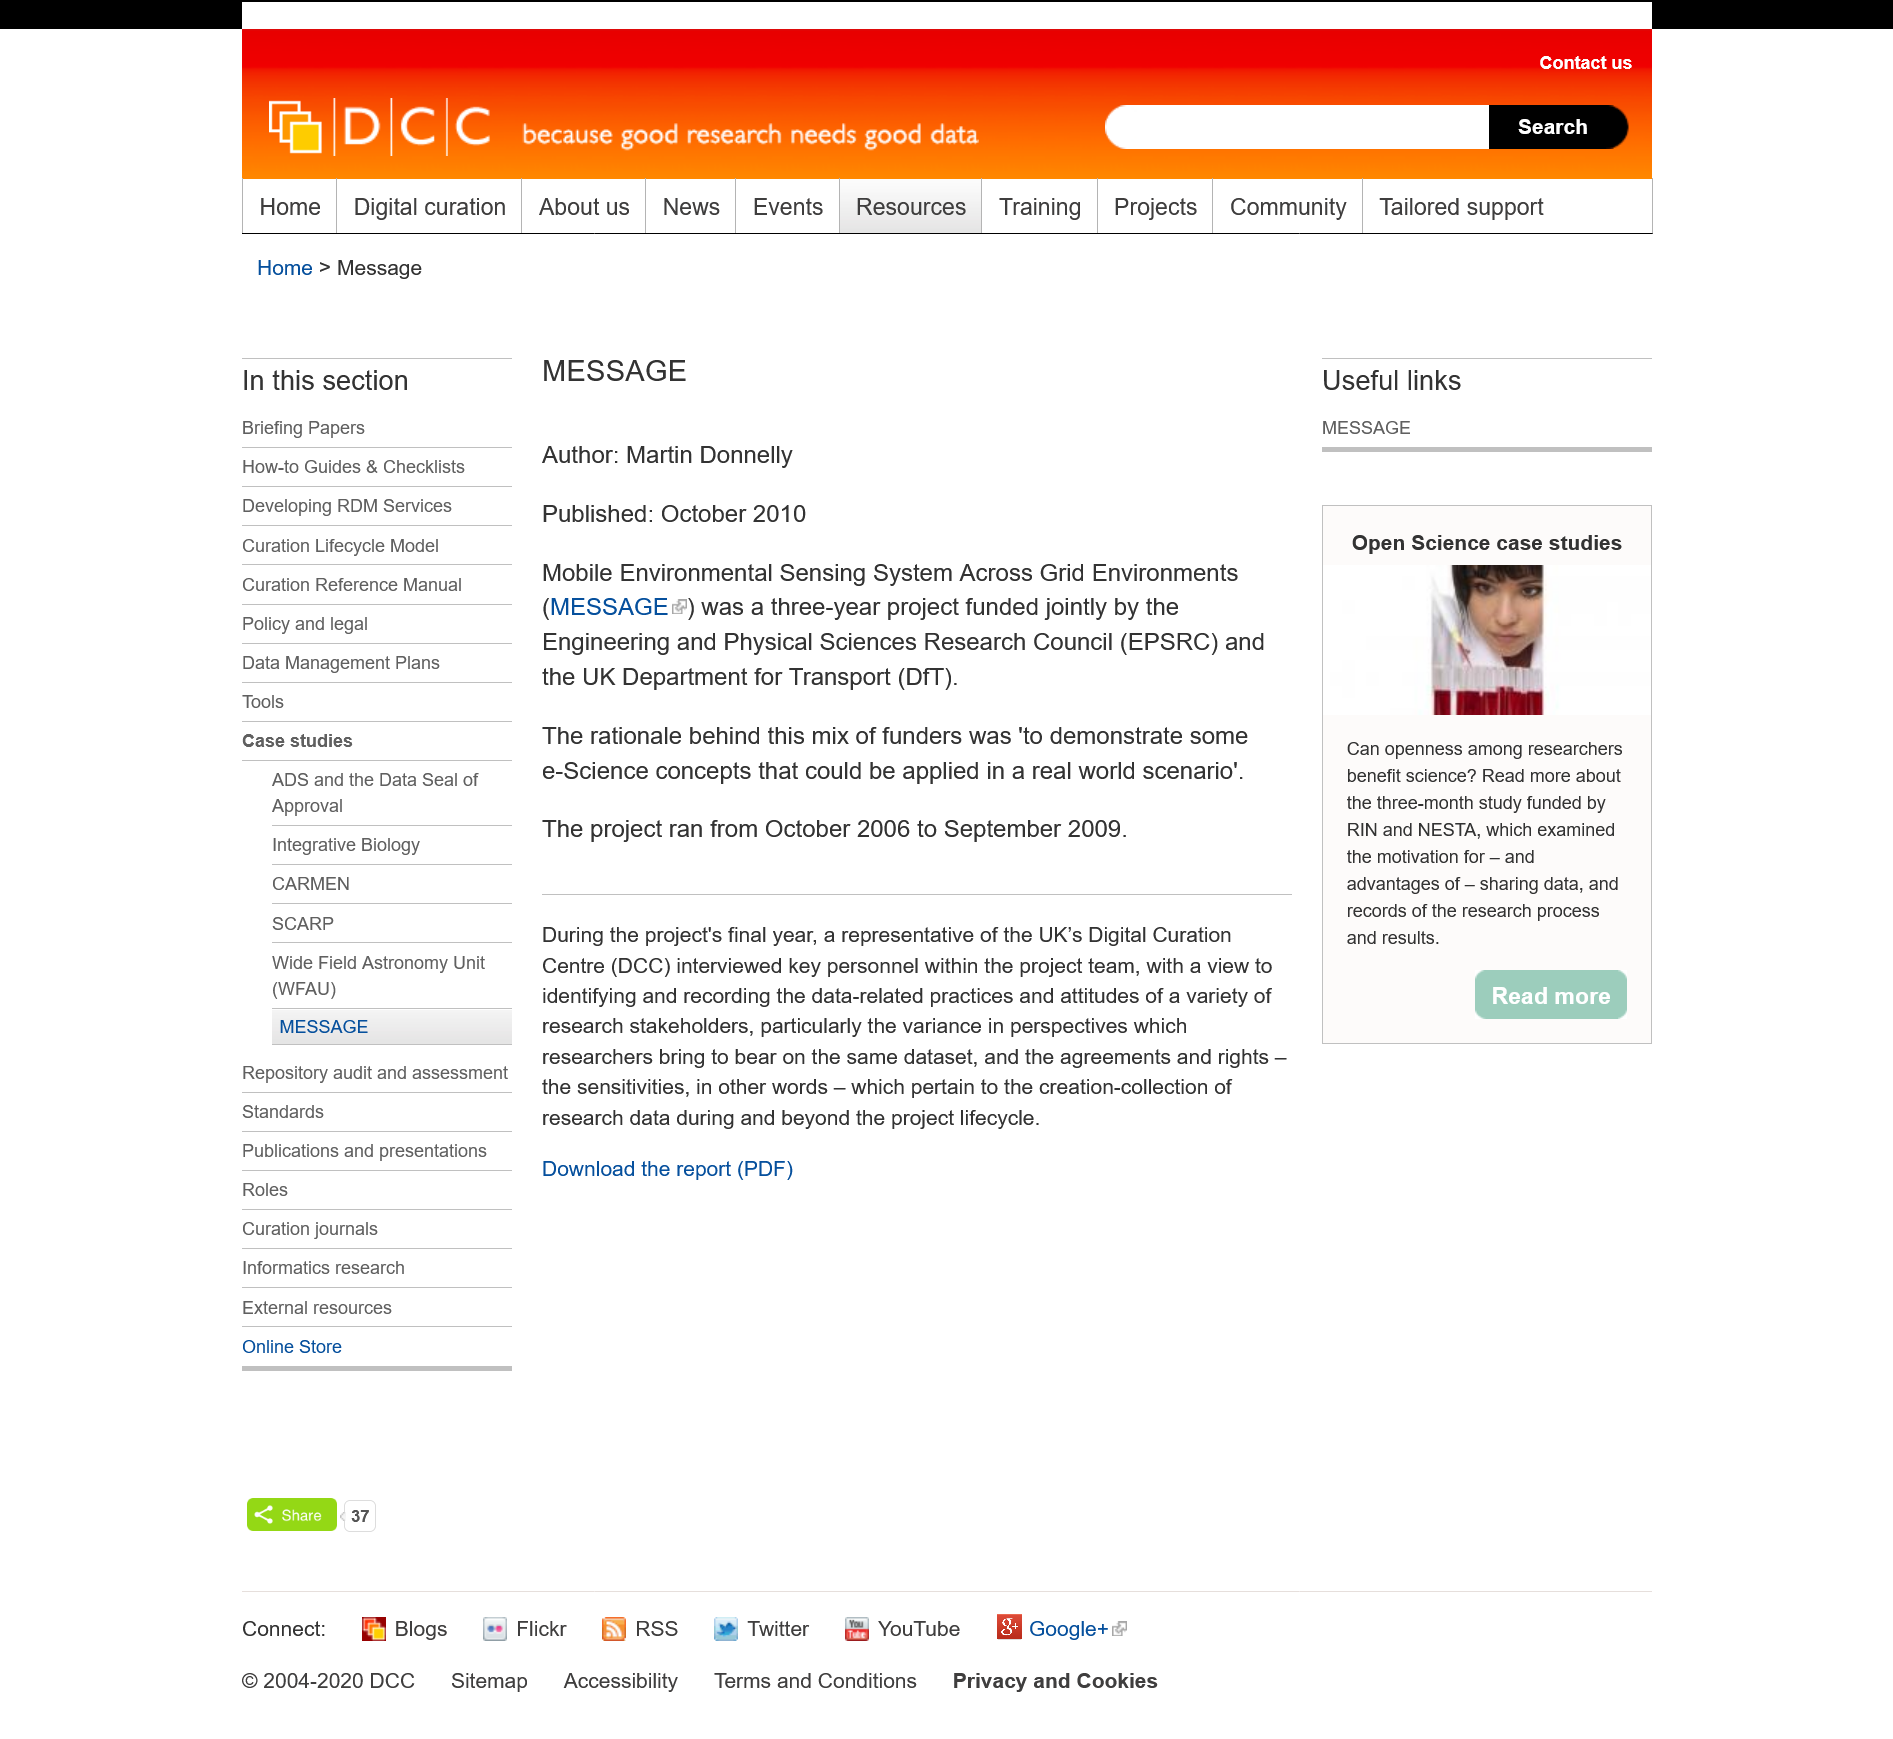Point out several critical features in this image. The Department for Transport (DfT) and the Engineering and Physical Sciences Research Council (EPSRC) selected this project for funding to demonstrate the application of e-science concepts to a real-world scenario. The acronym "MESSAGE" stands for a Mobile Environmental Sensing System Across Grid Environments. This system is designed to collect and analyze environmental data in various grid environments using mobile devices. The project ran for a total of three years. 